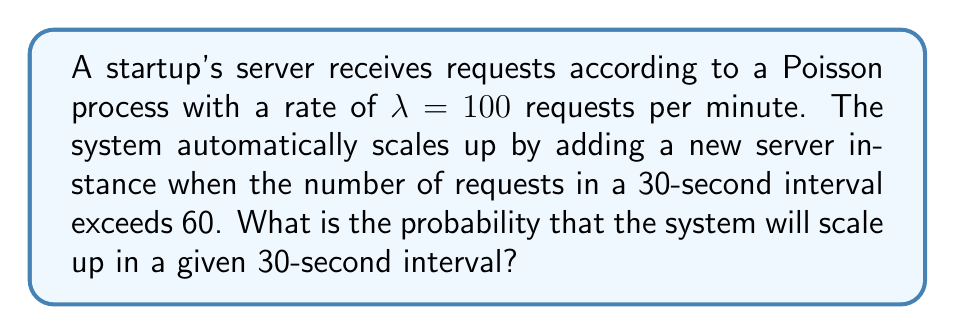Help me with this question. To solve this problem, we'll follow these steps:

1) First, we need to determine the rate parameter for a 30-second interval. Given that $\lambda = 100$ requests per minute, for a 30-second interval:

   $\lambda_{30s} = 100 \times \frac{30}{60} = 50$ requests per 30 seconds

2) The number of requests in a fixed time interval in a Poisson process follows a Poisson distribution. The probability of having more than 60 requests in a 30-second interval is equivalent to the probability of having 61 or more requests.

3) We can calculate this using the cumulative distribution function (CDF) of the Poisson distribution:

   $P(X > 60) = 1 - P(X \leq 60)$

4) The CDF of a Poisson distribution is given by:

   $P(X \leq k) = e^{-\lambda} \sum_{i=0}^k \frac{\lambda^i}{i!}$

5) Therefore, we need to calculate:

   $P(X > 60) = 1 - e^{-50} \sum_{i=0}^{60} \frac{50^i}{i!}$

6) This calculation is complex to do by hand, so we would typically use statistical software or programming languages to compute it. Using such tools, we find:

   $P(X > 60) \approx 0.0559$

This means there's approximately a 5.59% chance that the system will scale up in a given 30-second interval.
Answer: 0.0559 or 5.59% 